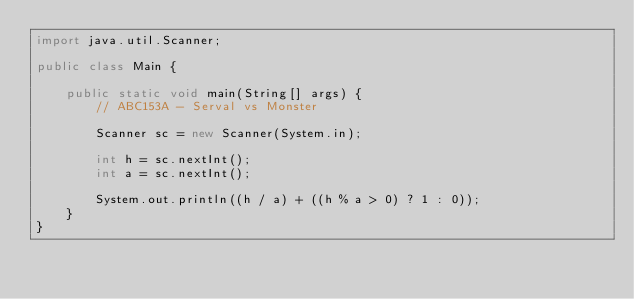Convert code to text. <code><loc_0><loc_0><loc_500><loc_500><_Java_>import java.util.Scanner;

public class Main {

    public static void main(String[] args) {
        // ABC153A - Serval vs Monster

        Scanner sc = new Scanner(System.in);

        int h = sc.nextInt();
        int a = sc.nextInt();

        System.out.println((h / a) + ((h % a > 0) ? 1 : 0));
    }
}</code> 